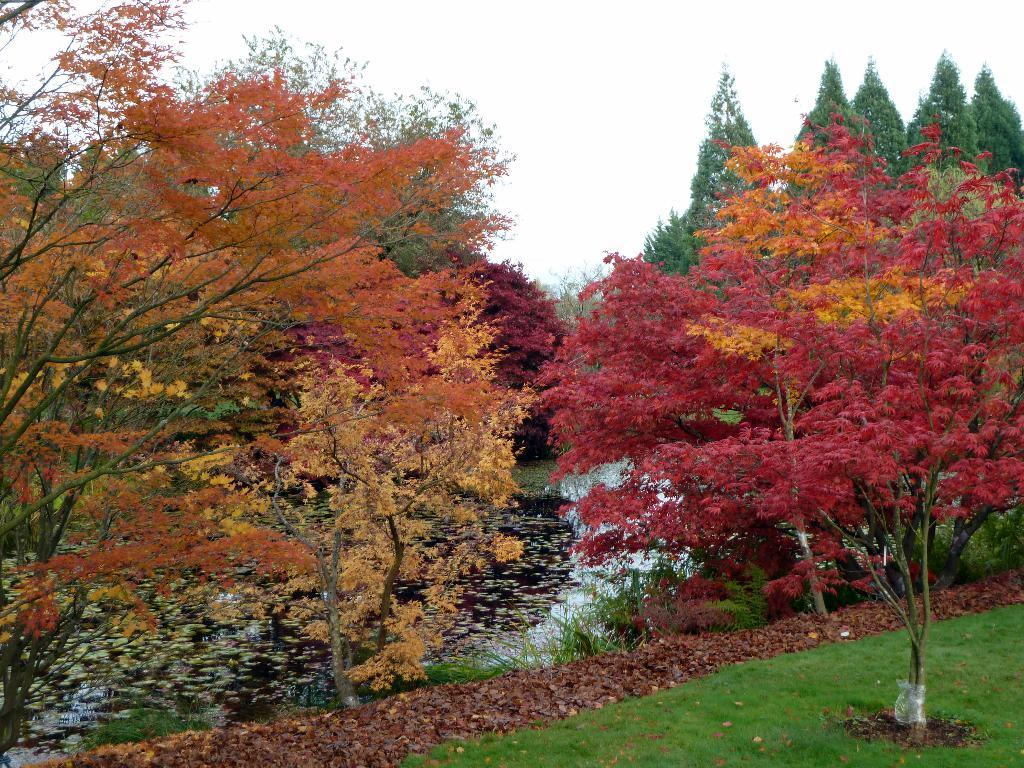What type of vegetation can be seen in the image? There are many trees in the image. What is located behind the trees? Water is present behind the trees. Where is the grassy land situated in the image? The grassy land is in the bottom right corner of the image. What type of vessel is present in the image? There is no vessel present in the image. 